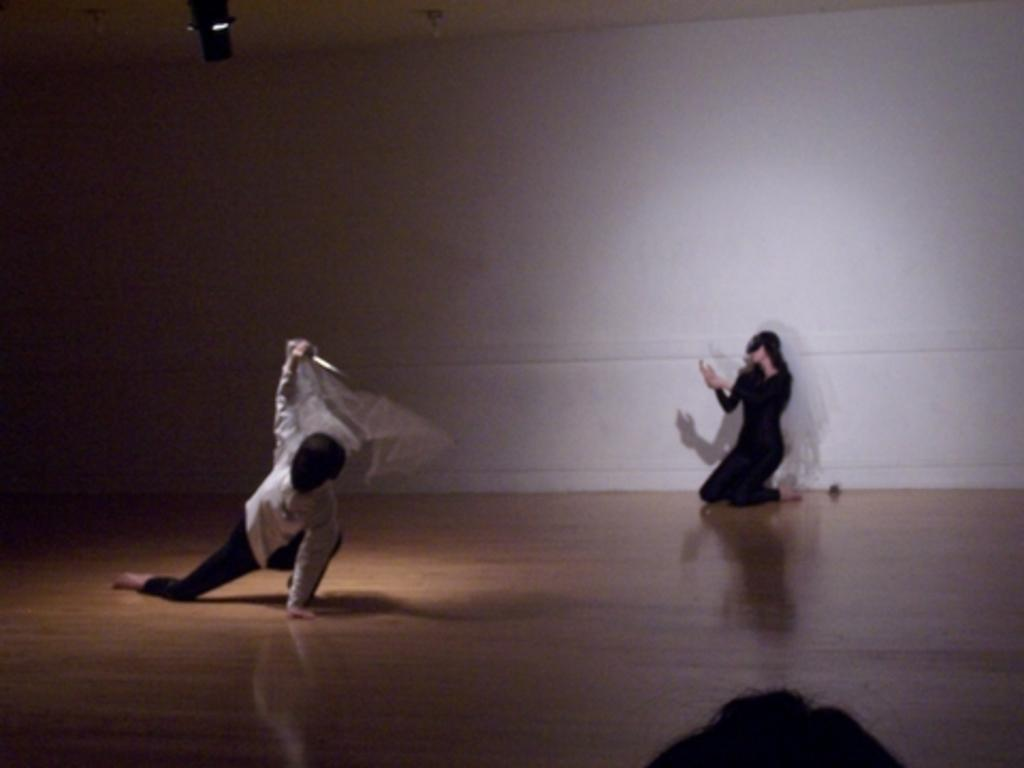What is the man doing on the left side of the image? The man is performing an action on the left side of the image. Who is on the right side of the image? There is a woman on the right side of the image. What is the woman wearing? The woman is wearing a black dress. What is the woman doing in the image? The woman is performing an action in the image. What is the profit made by the fairies in the image? There are no fairies present in the image, so there is no profit to discuss. 